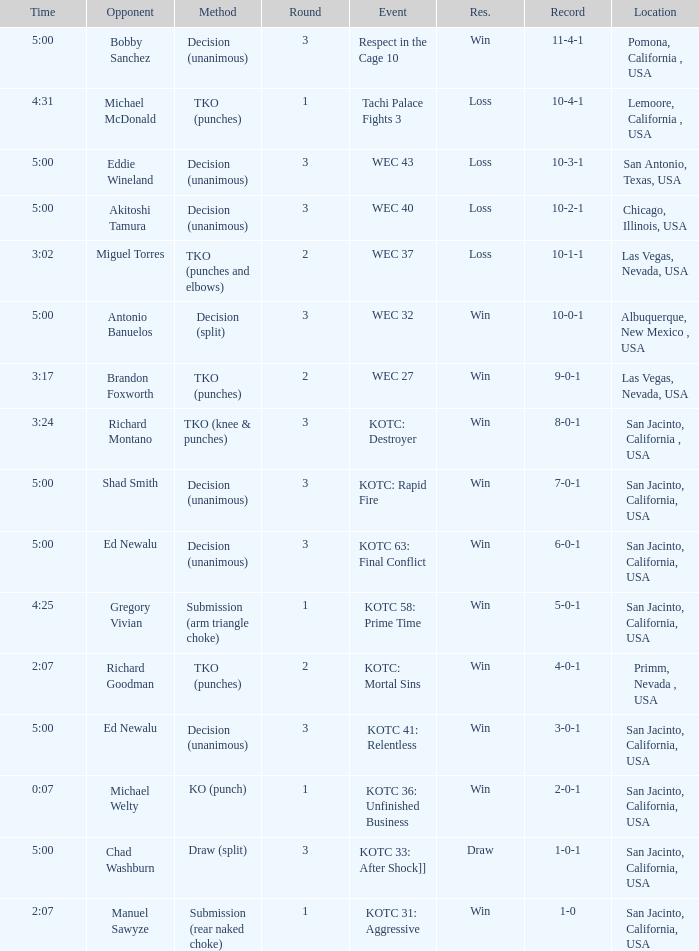What time did the even tachi palace fights 3 take place? 4:31. 